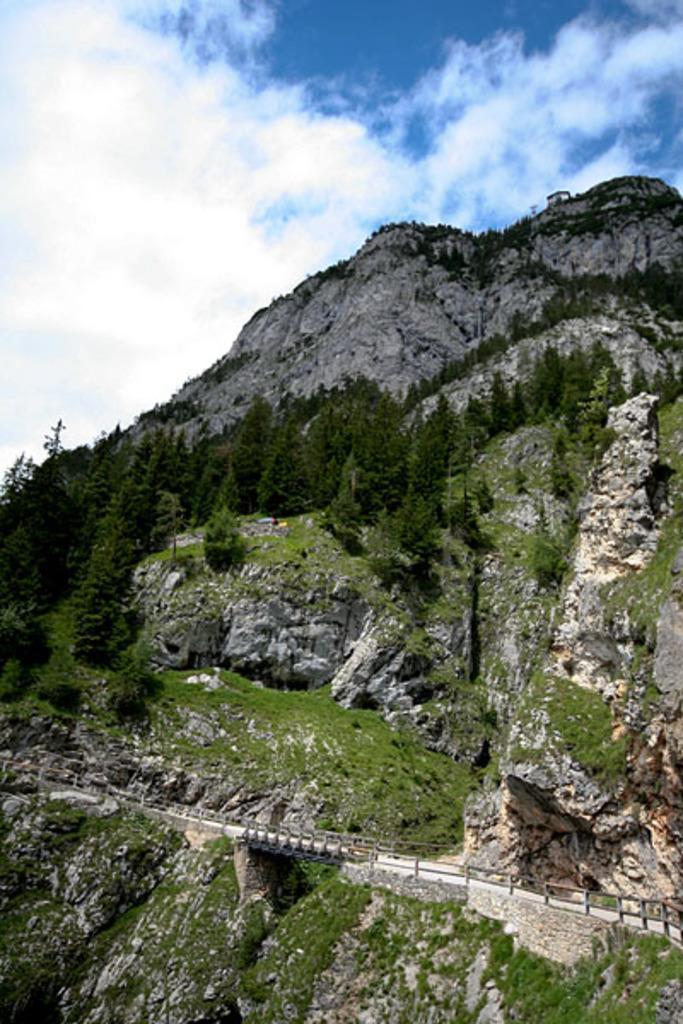Please provide a concise description of this image. In the background we can see the sky and clouds. This picture is mainly highlighted with the hills and the thicket. We can see the road and the railing. 